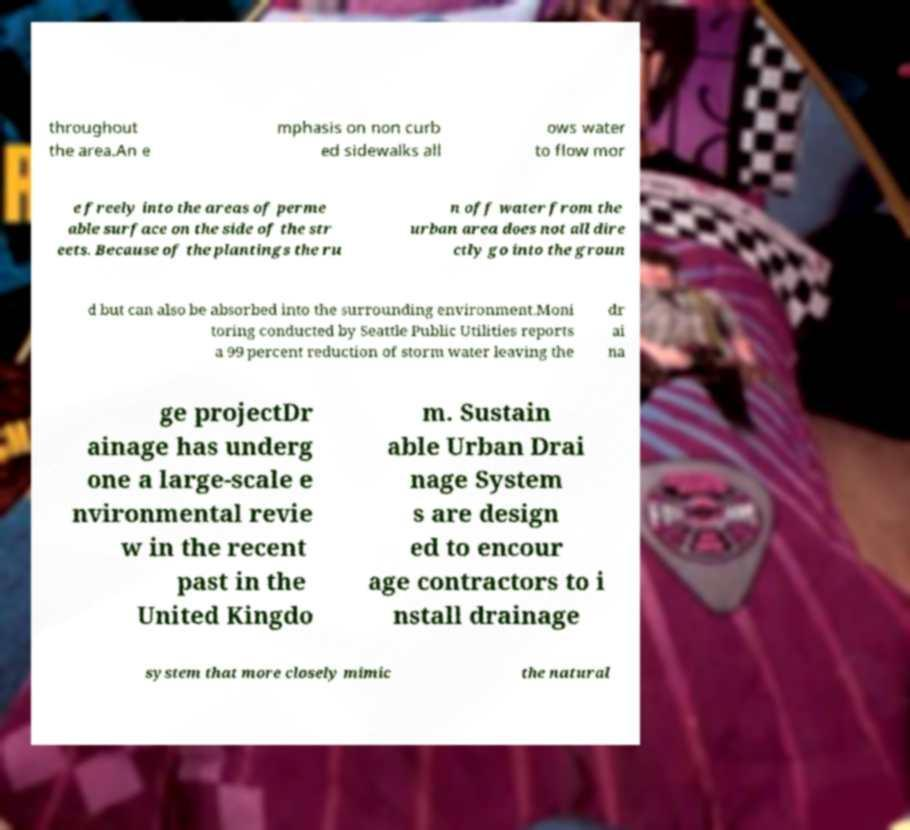Could you extract and type out the text from this image? throughout the area.An e mphasis on non curb ed sidewalks all ows water to flow mor e freely into the areas of perme able surface on the side of the str eets. Because of the plantings the ru n off water from the urban area does not all dire ctly go into the groun d but can also be absorbed into the surrounding environment.Moni toring conducted by Seattle Public Utilities reports a 99 percent reduction of storm water leaving the dr ai na ge projectDr ainage has underg one a large-scale e nvironmental revie w in the recent past in the United Kingdo m. Sustain able Urban Drai nage System s are design ed to encour age contractors to i nstall drainage system that more closely mimic the natural 